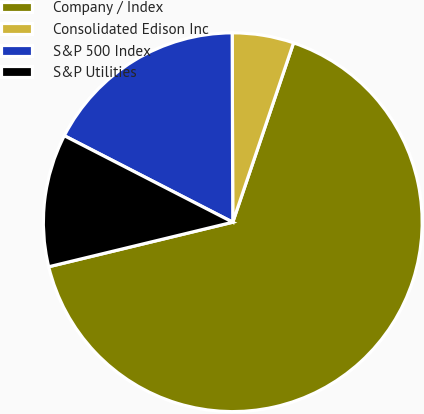Convert chart to OTSL. <chart><loc_0><loc_0><loc_500><loc_500><pie_chart><fcel>Company / Index<fcel>Consolidated Edison Inc<fcel>S&P 500 Index<fcel>S&P Utilities<nl><fcel>66.02%<fcel>5.25%<fcel>17.4%<fcel>11.33%<nl></chart> 